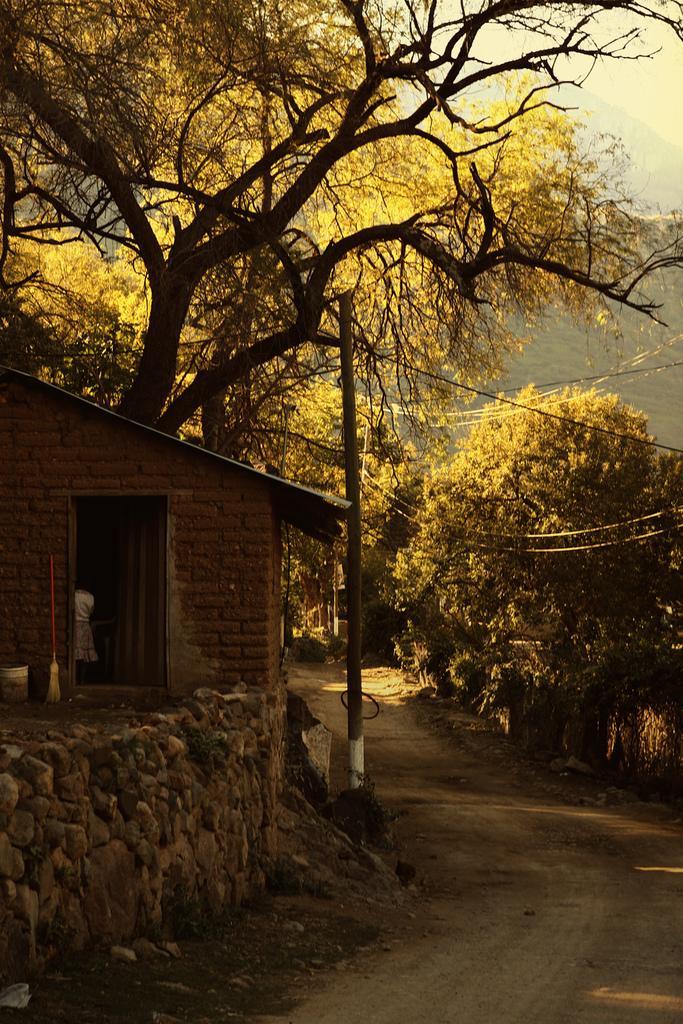In one or two sentences, can you explain what this image depicts? In this image we can see a person standing inside a house, a bucket and a broom which are placed beside a wall. We can also see a pole with a wire, a wall with stones, the pathway, a group of trees, the hill and the sky which looks cloudy. 